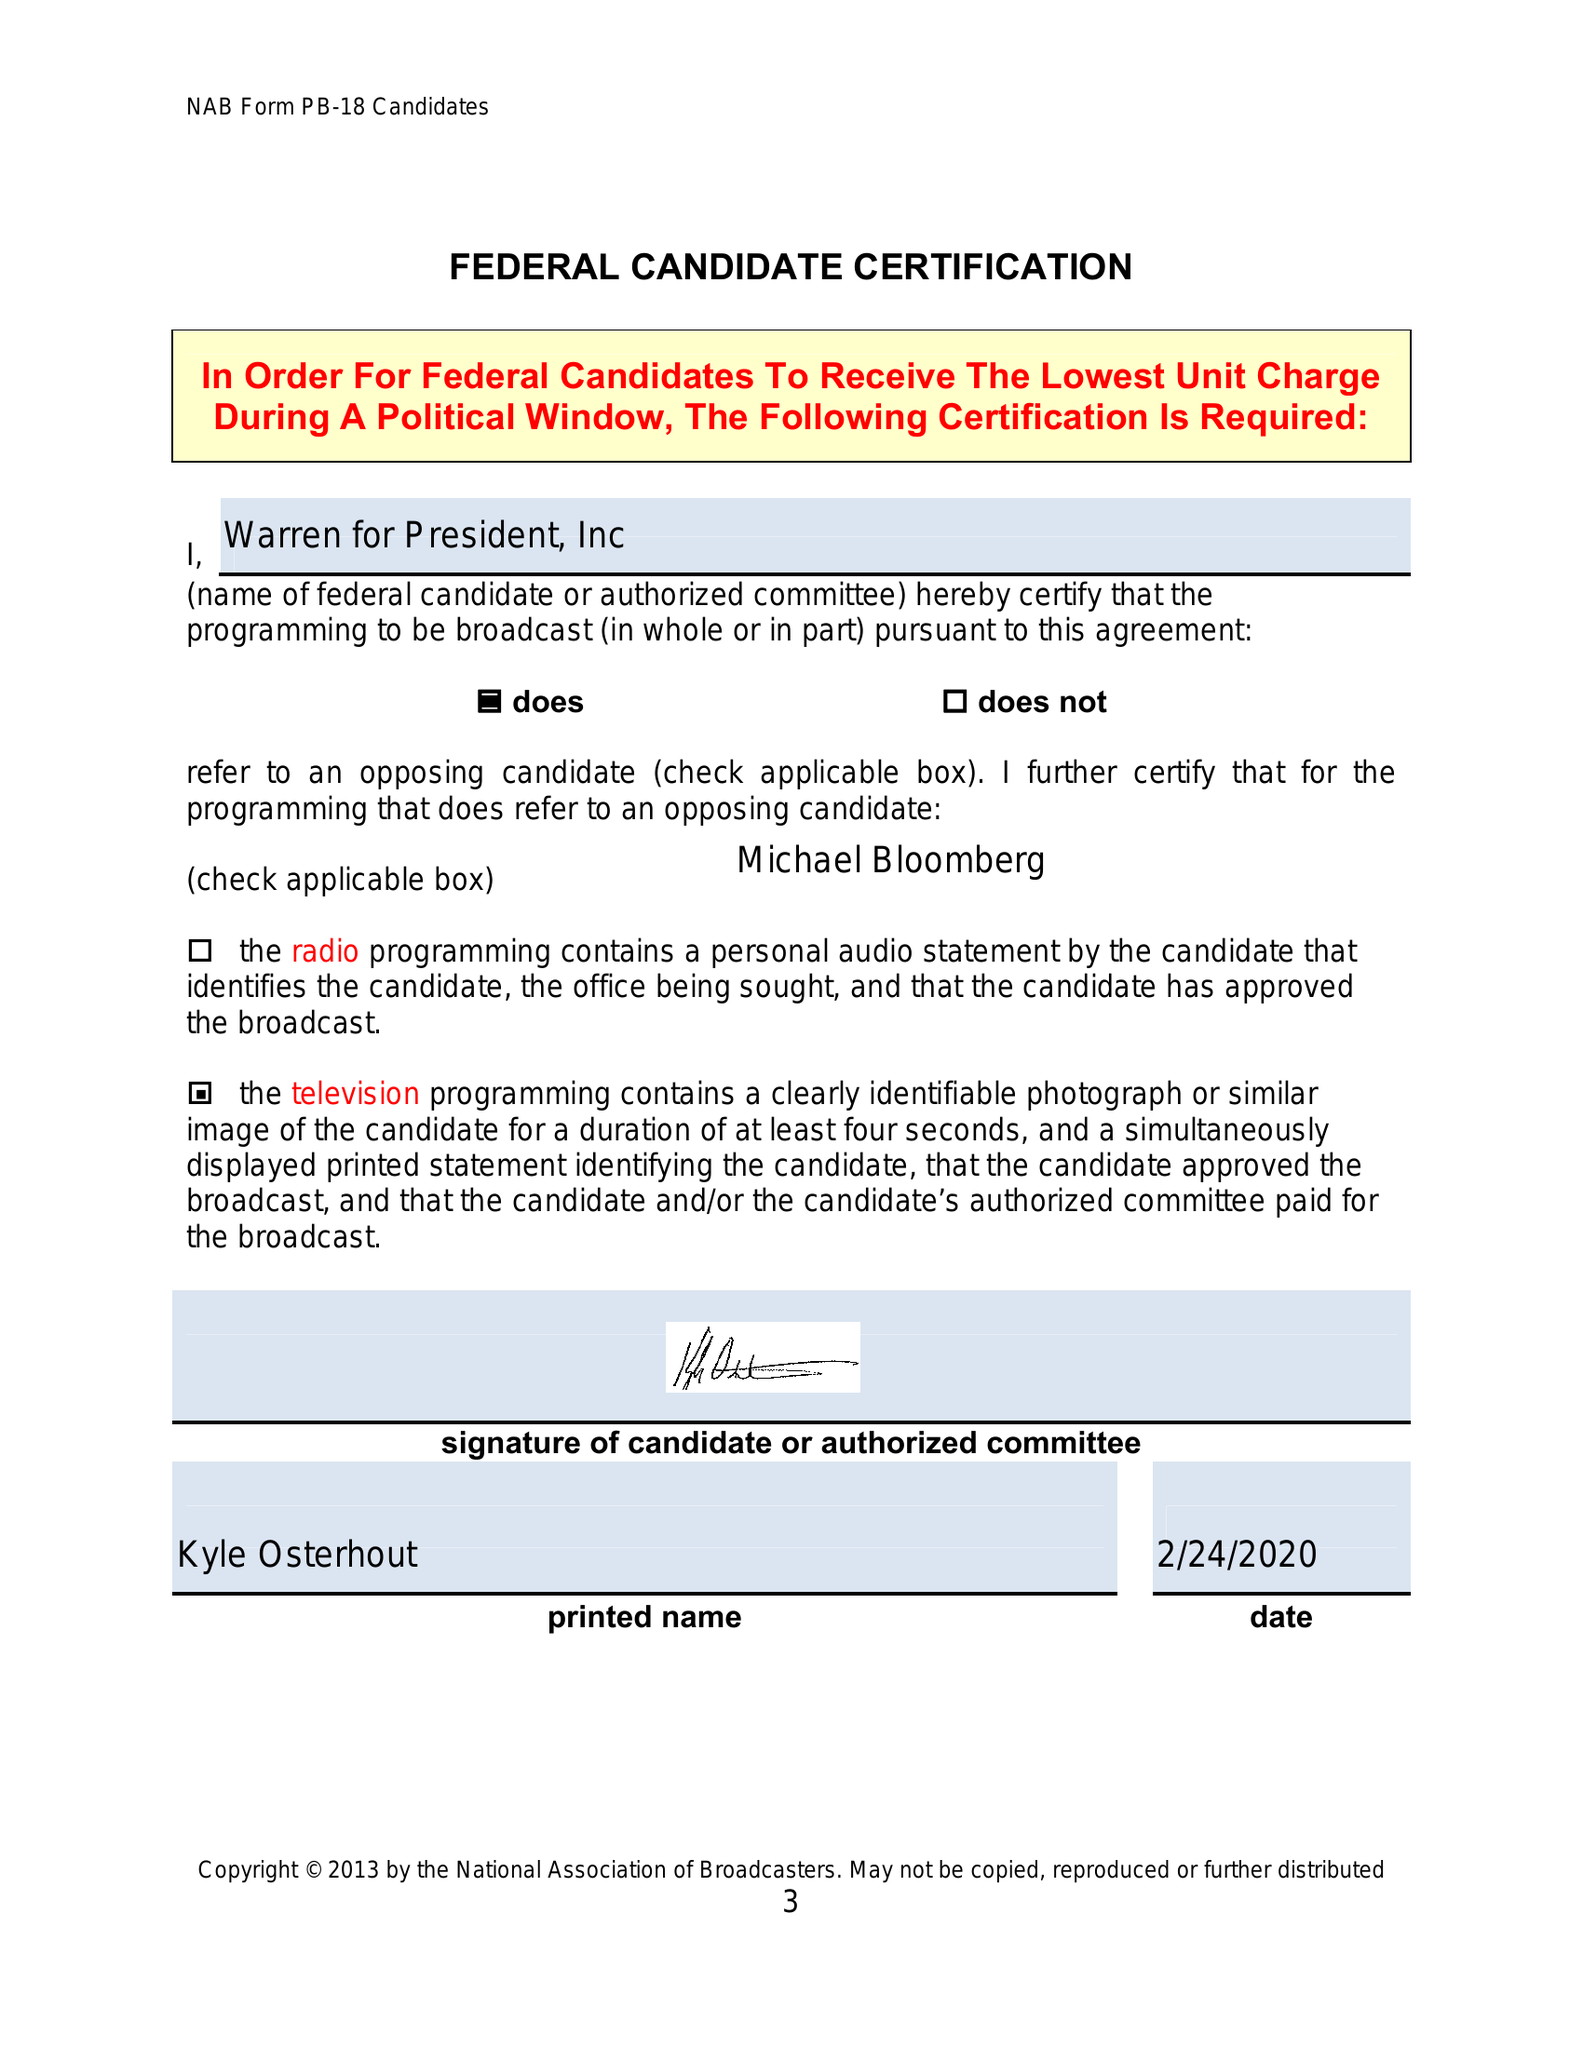What is the value for the advertiser?
Answer the question using a single word or phrase. None 